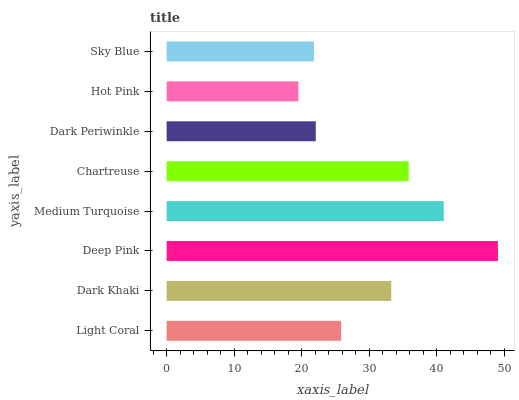Is Hot Pink the minimum?
Answer yes or no. Yes. Is Deep Pink the maximum?
Answer yes or no. Yes. Is Dark Khaki the minimum?
Answer yes or no. No. Is Dark Khaki the maximum?
Answer yes or no. No. Is Dark Khaki greater than Light Coral?
Answer yes or no. Yes. Is Light Coral less than Dark Khaki?
Answer yes or no. Yes. Is Light Coral greater than Dark Khaki?
Answer yes or no. No. Is Dark Khaki less than Light Coral?
Answer yes or no. No. Is Dark Khaki the high median?
Answer yes or no. Yes. Is Light Coral the low median?
Answer yes or no. Yes. Is Chartreuse the high median?
Answer yes or no. No. Is Dark Periwinkle the low median?
Answer yes or no. No. 